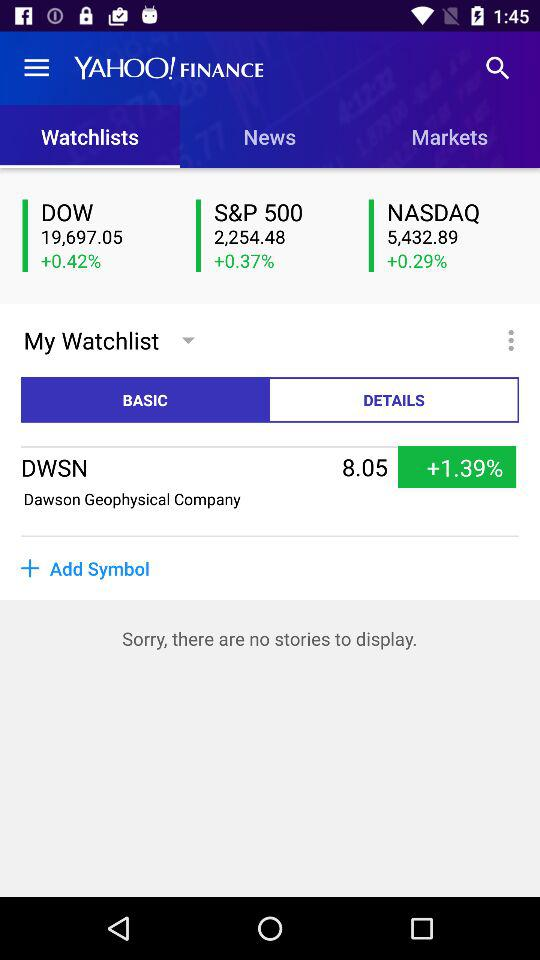What is the percentage increase in the DOW? The percentage increase is 0.42. 